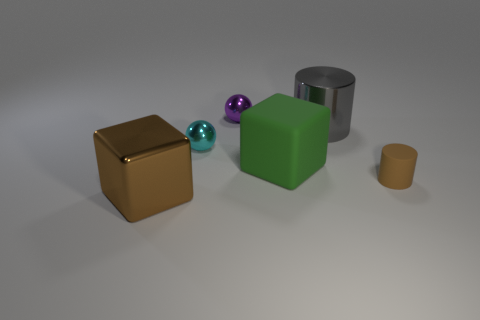Add 2 large rubber cylinders. How many objects exist? 8 Subtract all cylinders. How many objects are left? 4 Subtract 1 gray cylinders. How many objects are left? 5 Subtract all cylinders. Subtract all shiny cylinders. How many objects are left? 3 Add 1 brown metallic things. How many brown metallic things are left? 2 Add 2 matte balls. How many matte balls exist? 2 